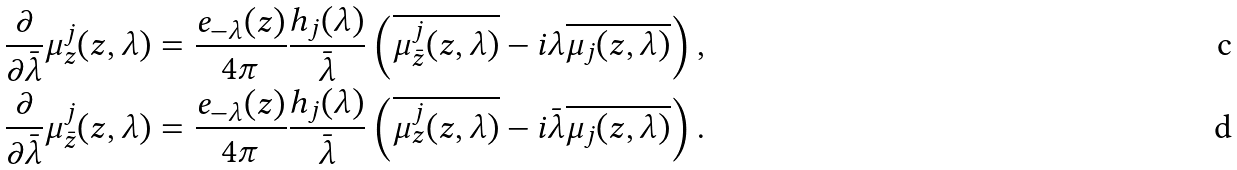Convert formula to latex. <formula><loc_0><loc_0><loc_500><loc_500>\frac { \partial } { \partial \bar { \lambda } } \mu _ { z } ^ { j } ( z , \lambda ) = \frac { e _ { - \lambda } ( z ) } { 4 \pi } \frac { h _ { j } ( \lambda ) } { \bar { \lambda } } \left ( \overline { \mu _ { \bar { z } } ^ { j } ( z , \lambda ) } - i \lambda \overline { \mu _ { j } ( z , \lambda ) } \right ) , \\ \frac { \partial } { \partial \bar { \lambda } } \mu _ { \bar { z } } ^ { j } ( z , \lambda ) = \frac { e _ { - \lambda } ( z ) } { 4 \pi } \frac { h _ { j } ( \lambda ) } { \bar { \lambda } } \left ( \overline { \mu _ { z } ^ { j } ( z , \lambda ) } - i \bar { \lambda } \overline { \mu _ { j } ( z , \lambda ) } \right ) .</formula> 